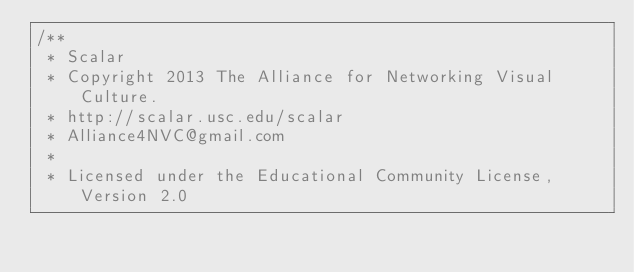<code> <loc_0><loc_0><loc_500><loc_500><_JavaScript_>/**
 * Scalar
 * Copyright 2013 The Alliance for Networking Visual Culture.
 * http://scalar.usc.edu/scalar
 * Alliance4NVC@gmail.com
 *
 * Licensed under the Educational Community License, Version 2.0</code> 